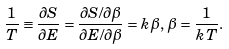Convert formula to latex. <formula><loc_0><loc_0><loc_500><loc_500>\frac { 1 } { T } \equiv \frac { \partial S } { \partial E } = \frac { \partial S / \partial \beta } { \partial E / \partial \beta } = k \beta , \, \beta = \frac { 1 } { k T } .</formula> 